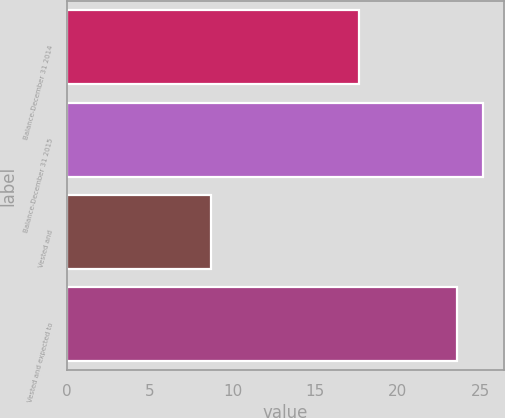<chart> <loc_0><loc_0><loc_500><loc_500><bar_chart><fcel>Balance-December 31 2014<fcel>Balance-December 31 2015<fcel>Vested and<fcel>Vested and expected to<nl><fcel>17.63<fcel>25.15<fcel>8.68<fcel>23.57<nl></chart> 